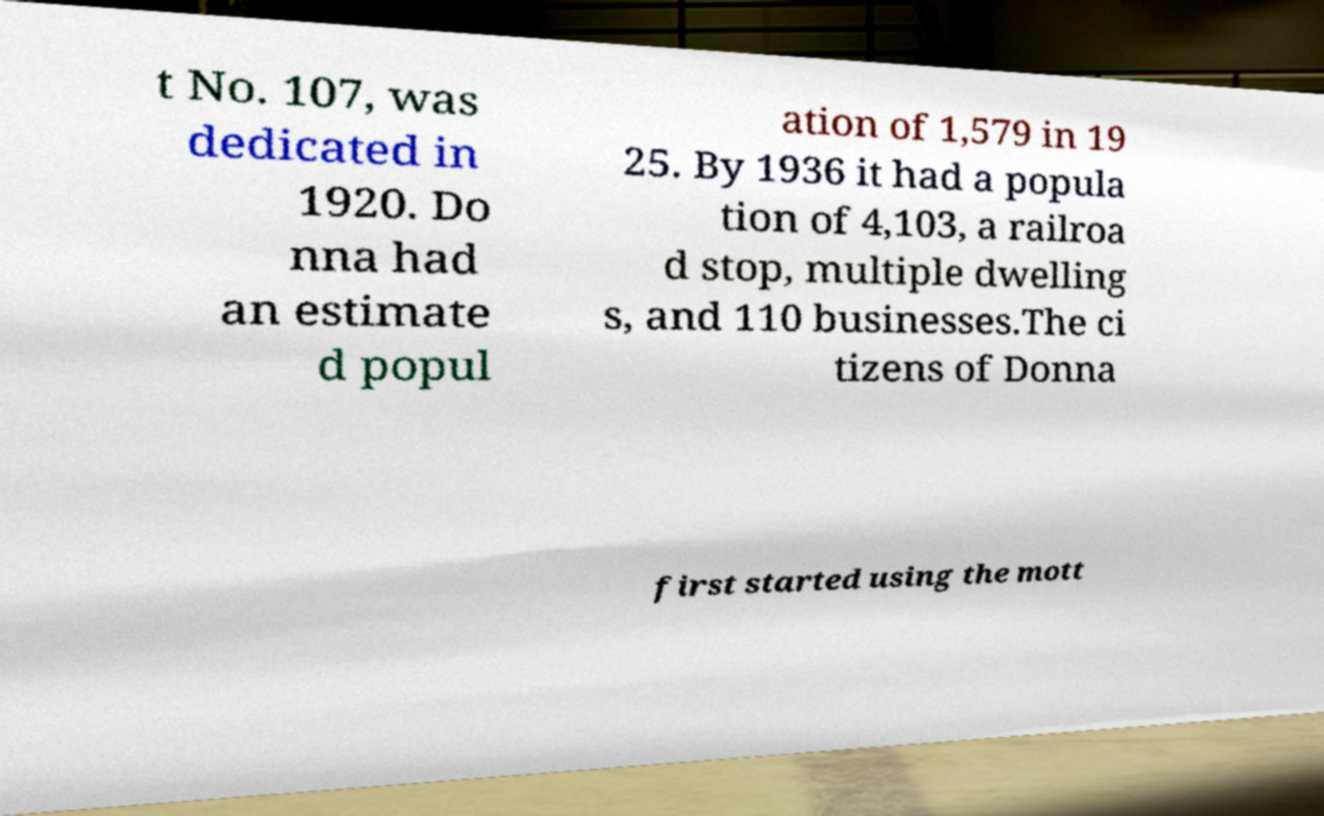For documentation purposes, I need the text within this image transcribed. Could you provide that? t No. 107, was dedicated in 1920. Do nna had an estimate d popul ation of 1,579 in 19 25. By 1936 it had a popula tion of 4,103, a railroa d stop, multiple dwelling s, and 110 businesses.The ci tizens of Donna first started using the mott 